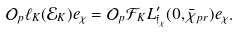<formula> <loc_0><loc_0><loc_500><loc_500>\mathcal { O } _ { p } \ell _ { K } ( \mathcal { E } _ { K } ) e _ { \chi } = \mathcal { O } _ { p } \mathcal { F } _ { K } L ^ { \prime } _ { \mathfrak { f } _ { \chi } } ( 0 , \bar { \chi } _ { p r } ) e _ { \chi } .</formula> 